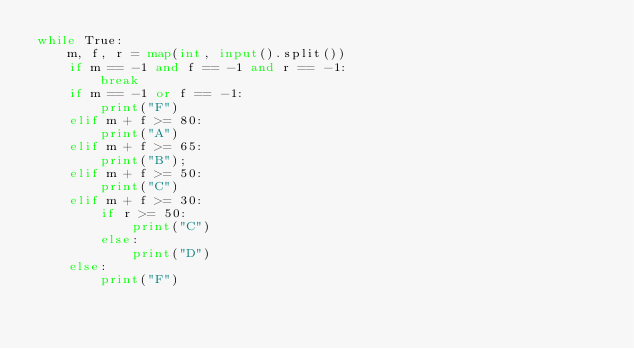<code> <loc_0><loc_0><loc_500><loc_500><_Python_>while True:
    m, f, r = map(int, input().split())
    if m == -1 and f == -1 and r == -1:
        break
    if m == -1 or f == -1:
        print("F")
    elif m + f >= 80:
        print("A")
    elif m + f >= 65:
        print("B");
    elif m + f >= 50:
        print("C")
    elif m + f >= 30:
        if r >= 50:
            print("C")
        else:
            print("D")
    else:
        print("F")
</code> 